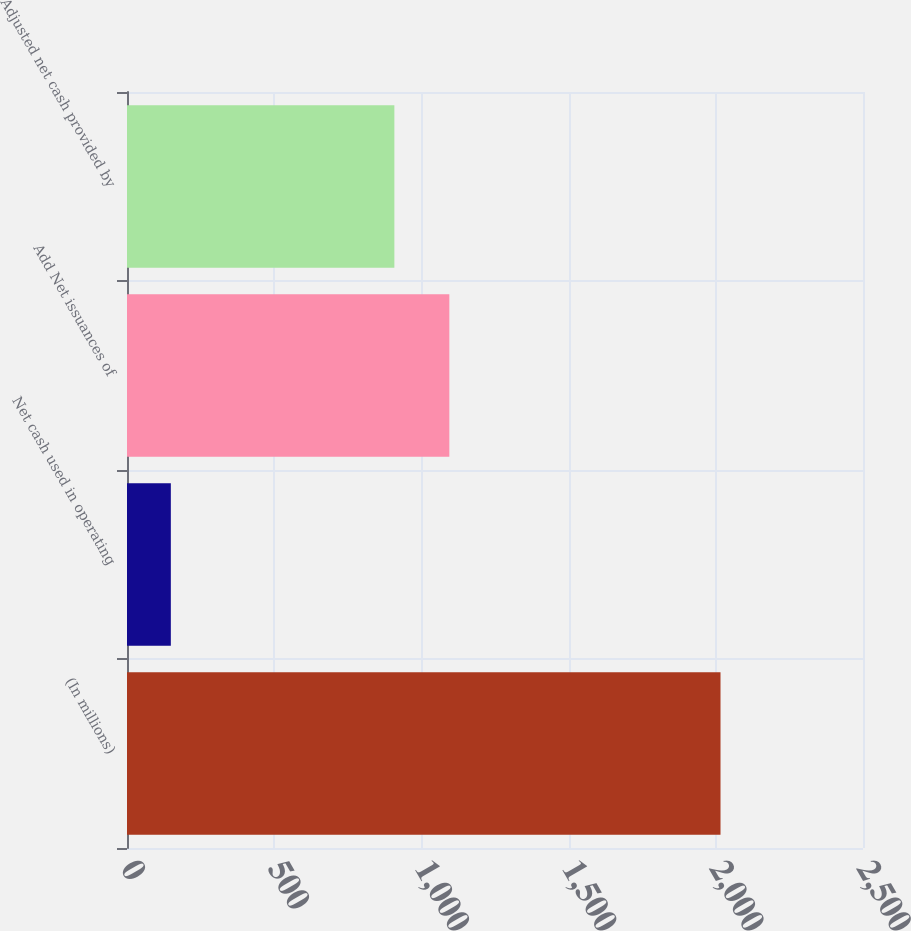<chart> <loc_0><loc_0><loc_500><loc_500><bar_chart><fcel>(In millions)<fcel>Net cash used in operating<fcel>Add Net issuances of<fcel>Adjusted net cash provided by<nl><fcel>2016<fcel>148.9<fcel>1094.91<fcel>908.2<nl></chart> 